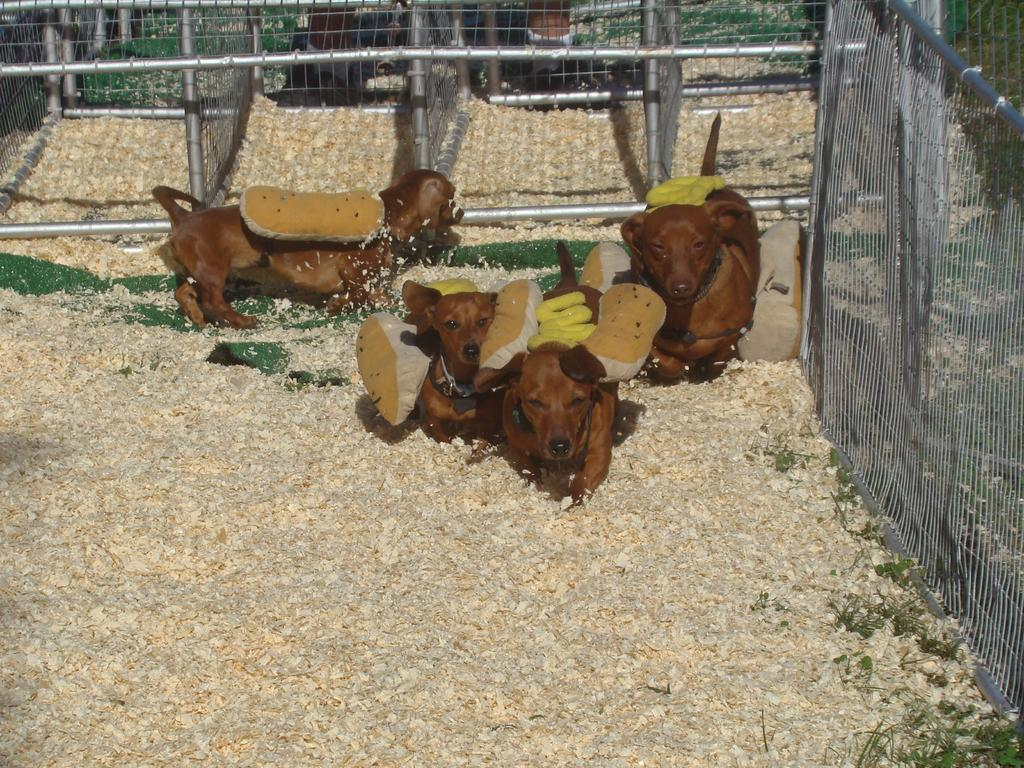How many dogs are present in the image? There are four dogs in the image. What is the color of the dogs? The dogs are brown in color. What can be seen in the background of the image? There is fencing in the image. What type of vegetation is visible in the image? There are plants on the ground in the top right side of the image. What type of muscle is being exercised by the dogs in the image? There is no indication in the image that the dogs are exercising any muscles; they are simply present in the image. 